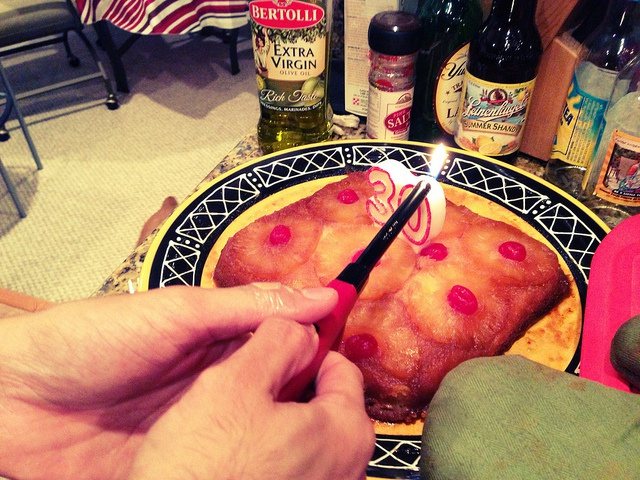Describe the objects in this image and their specific colors. I can see dining table in tan, black, olive, orange, and salmon tones, people in tan and salmon tones, cake in tan, salmon, and brown tones, people in tan, olive, and gray tones, and bottle in tan, black, khaki, and olive tones in this image. 